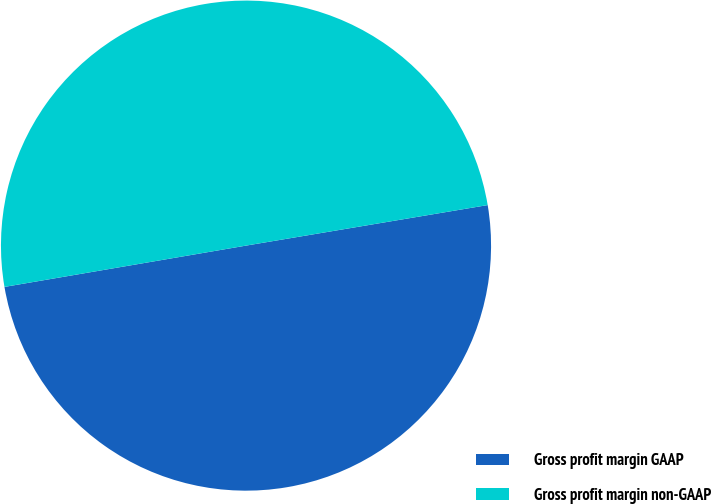Convert chart to OTSL. <chart><loc_0><loc_0><loc_500><loc_500><pie_chart><fcel>Gross profit margin GAAP<fcel>Gross profit margin non-GAAP<nl><fcel>49.95%<fcel>50.05%<nl></chart> 